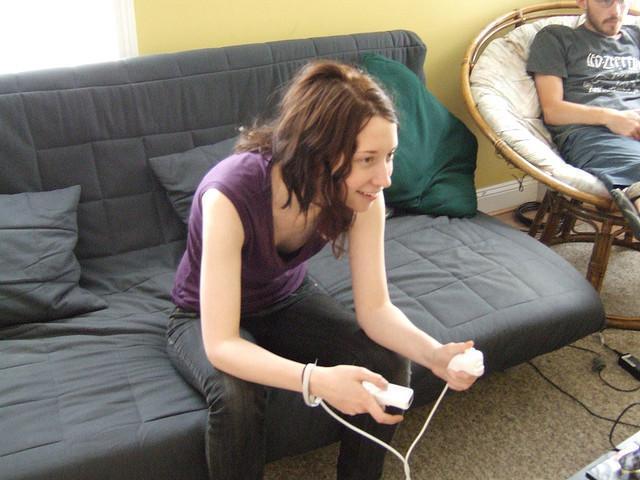What setting are these types of seating often seen in?
Choose the correct response and explain in the format: 'Answer: answer
Rationale: rationale.'
Options: Apartment, church, mansion, office. Answer: apartment.
Rationale: The people are sitting on casual furniture that is found in a cheap apartment. 